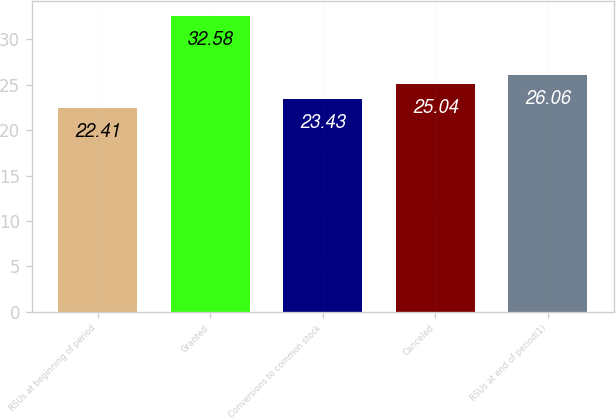Convert chart. <chart><loc_0><loc_0><loc_500><loc_500><bar_chart><fcel>RSUs at beginning of period<fcel>Granted<fcel>Conversions to common stock<fcel>Canceled<fcel>RSUs at end of period(1)<nl><fcel>22.41<fcel>32.58<fcel>23.43<fcel>25.04<fcel>26.06<nl></chart> 